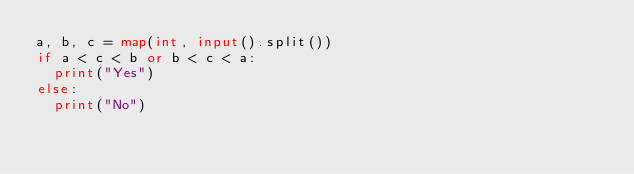<code> <loc_0><loc_0><loc_500><loc_500><_Python_>a, b, c = map(int, input().split())
if a < c < b or b < c < a:
	print("Yes")
else:
	print("No")
</code> 